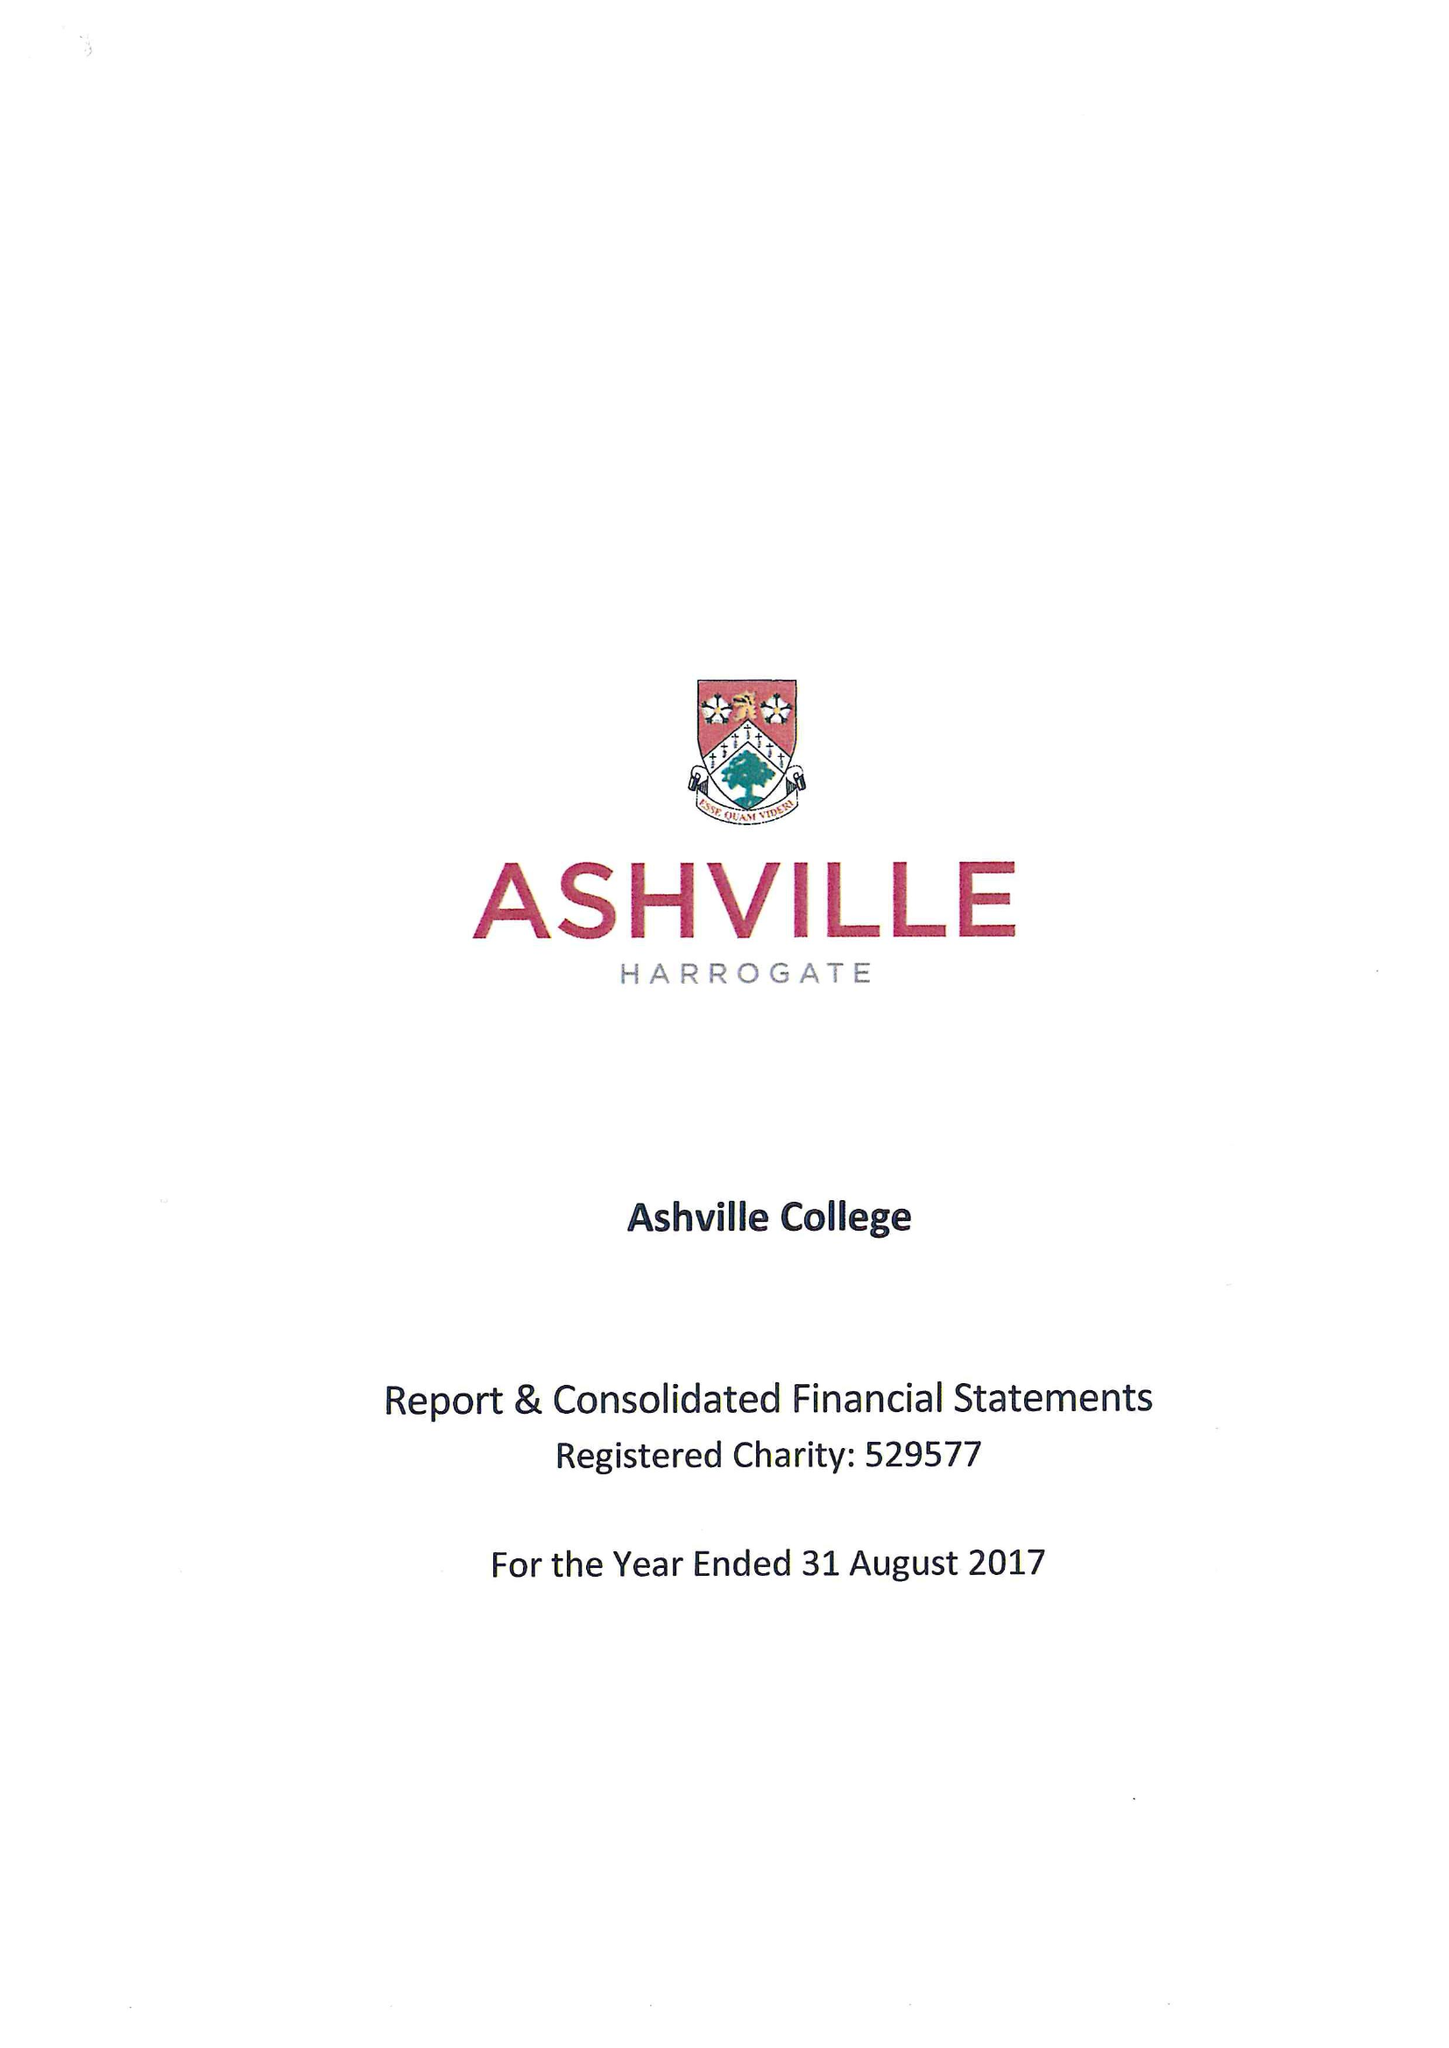What is the value for the charity_number?
Answer the question using a single word or phrase. 529577 